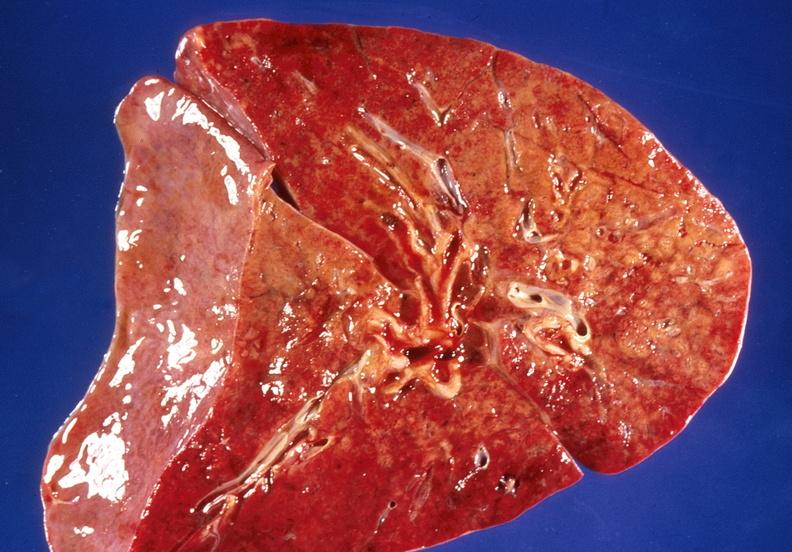does this image show lung, bronchopneumonia, cystic fibrosis?
Answer the question using a single word or phrase. Yes 